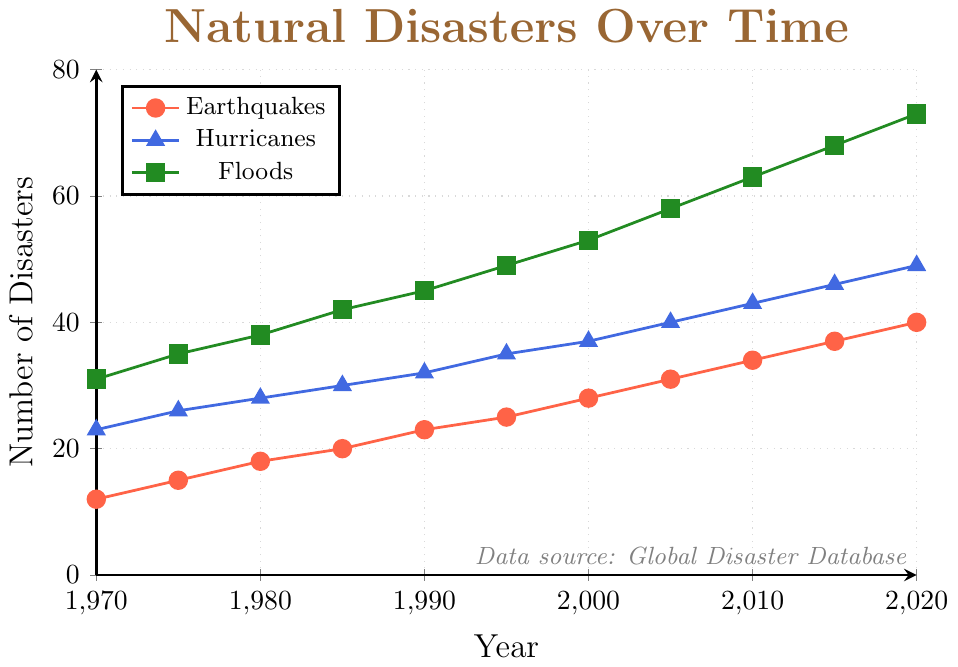Which natural disaster type had the highest increase over the period? To find the disaster type with the highest increase, subtract the initial (1970) value from the final (2020) value for each type. Earthquakes increased by \(40 - 12 = 28\), Hurricanes by \(49 - 23 = 26\), and Floods by \(73 - 31 = 42\). Floods have the highest increase.
Answer: Floods By how much did the number of hurricanes increase from 2000 to 2010? In 2000, there were 37 hurricanes, and in 2010, there were 43 hurricanes. Subtract 37 from 43. \(43 - 37 = 6\).
Answer: 6 Which year experienced the same number of earthquakes and hurricanes? Look at the years where the earthquake and hurricane lines intersect. In this data, the lines never intersect.
Answer: Never What is the average number of floods over the entire period? Sum the number of floods for each year and divide by the number of years. \(31 + 35 + 38 + 42 + 45 + 49 + 53 + 58 + 63 + 68 + 73 = 555\). The number of years is 11. \(555 / 11 = 50.45\).
Answer: 50.45 How many more floods than earthquakes were there in 1985? In 1985, there were 42 floods and 20 earthquakes. Subtract the number of earthquakes from the number of floods. \(42 - 20 = 22\).
Answer: 22 Between which five-year period did hurricanes experience the greatest increase? Calculate the difference between the number of hurricanes for each successive five-year period. The periods are: 1970-1975 (3), 1975-1980 (2), 1980-1985 (2), 1985-1990 (2), 1990-1995 (3), 1995-2000 (2), 2000-2005 (3), 2005-2010 (3), 2010-2015 (3), 2015-2020 (3). The greatest increase happens during multiple periods with an increase of 3 hurricanes.
Answer: 1970-1975, 1990-1995, 2000-2005, 2005-2010, 2010-2015, 2015-2020 When did earthquakes and floods both reach 31 incidents for the first time? Check the years earthquakes and floods independently reached 31 incidents first. The earthquakes reached 31 incidents first in 2005. The floods reached 31 incidents in 1970.
Answer: 2005, 1970 Which disaster type consistently had the highest values each year? Observe the lines representing each disaster type through the years. The green line representing floods is always the highest.
Answer: Floods 